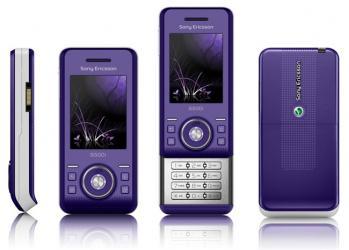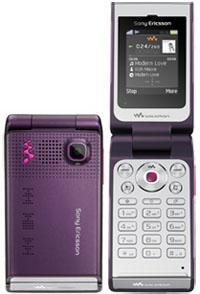The first image is the image on the left, the second image is the image on the right. Assess this claim about the two images: "There is an open flip phone in the image on the left.". Correct or not? Answer yes or no. No. The first image is the image on the left, the second image is the image on the right. Assess this claim about the two images: "Exactly one flip phone is open.". Correct or not? Answer yes or no. Yes. 